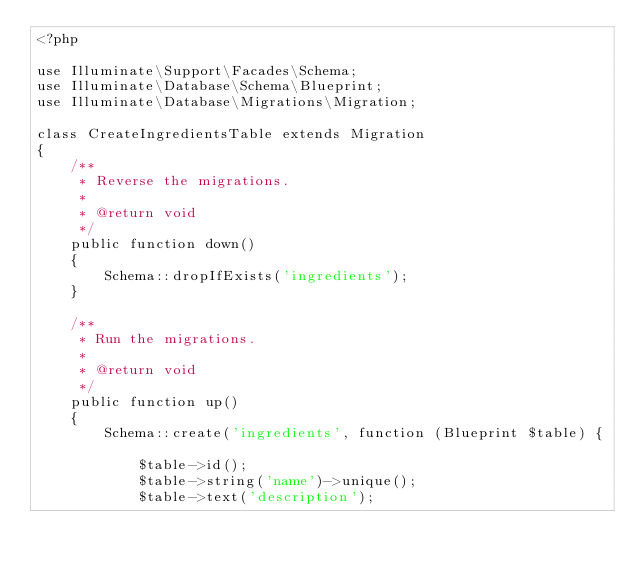Convert code to text. <code><loc_0><loc_0><loc_500><loc_500><_PHP_><?php

use Illuminate\Support\Facades\Schema;
use Illuminate\Database\Schema\Blueprint;
use Illuminate\Database\Migrations\Migration;

class CreateIngredientsTable extends Migration
{
    /**
     * Reverse the migrations.
     *
     * @return void
     */
    public function down()
    {
        Schema::dropIfExists('ingredients');
    }

    /**
     * Run the migrations.
     *
     * @return void
     */
    public function up()
    {
        Schema::create('ingredients', function (Blueprint $table) {

            $table->id();
            $table->string('name')->unique();
            $table->text('description');</code> 